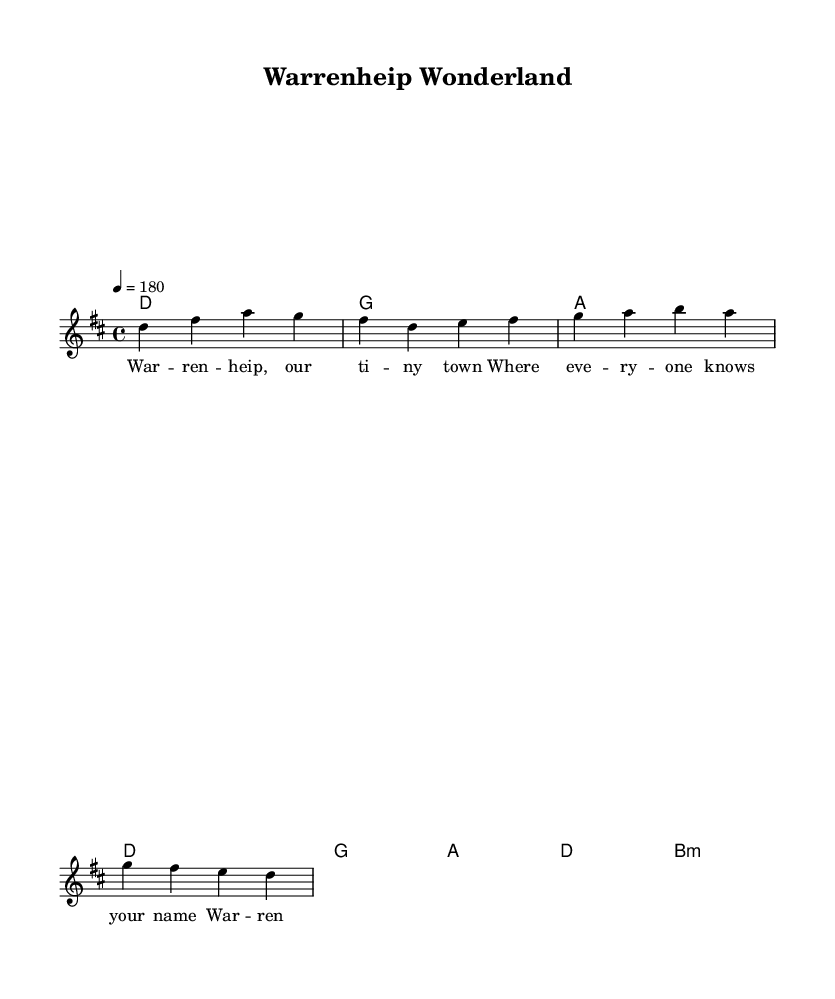What is the key signature of this music? The key signature is D major, which has two sharps (F# and C#).
Answer: D major What is the time signature of this music? The time signature is 4/4, meaning there are four beats per measure.
Answer: 4/4 What is the tempo indicated in this music? The tempo is marked at 180 beats per minute, indicating how fast the piece should be played.
Answer: 180 How many measures are in the melody section? The melody section has a total of 8 measures in both the verse and chorus combined.
Answer: 8 What is the structure of this song? The song consists of a verse followed by a chorus, repeated once.
Answer: Verse and Chorus What chord is played during the first measure? The first measure contains a D major chord, as indicated by the chord mode.
Answer: D What themes are captured in the lyrics? The lyrics capture feelings of community and pride in small-town life, conveying both challenges and joys.
Answer: Community and Pride 